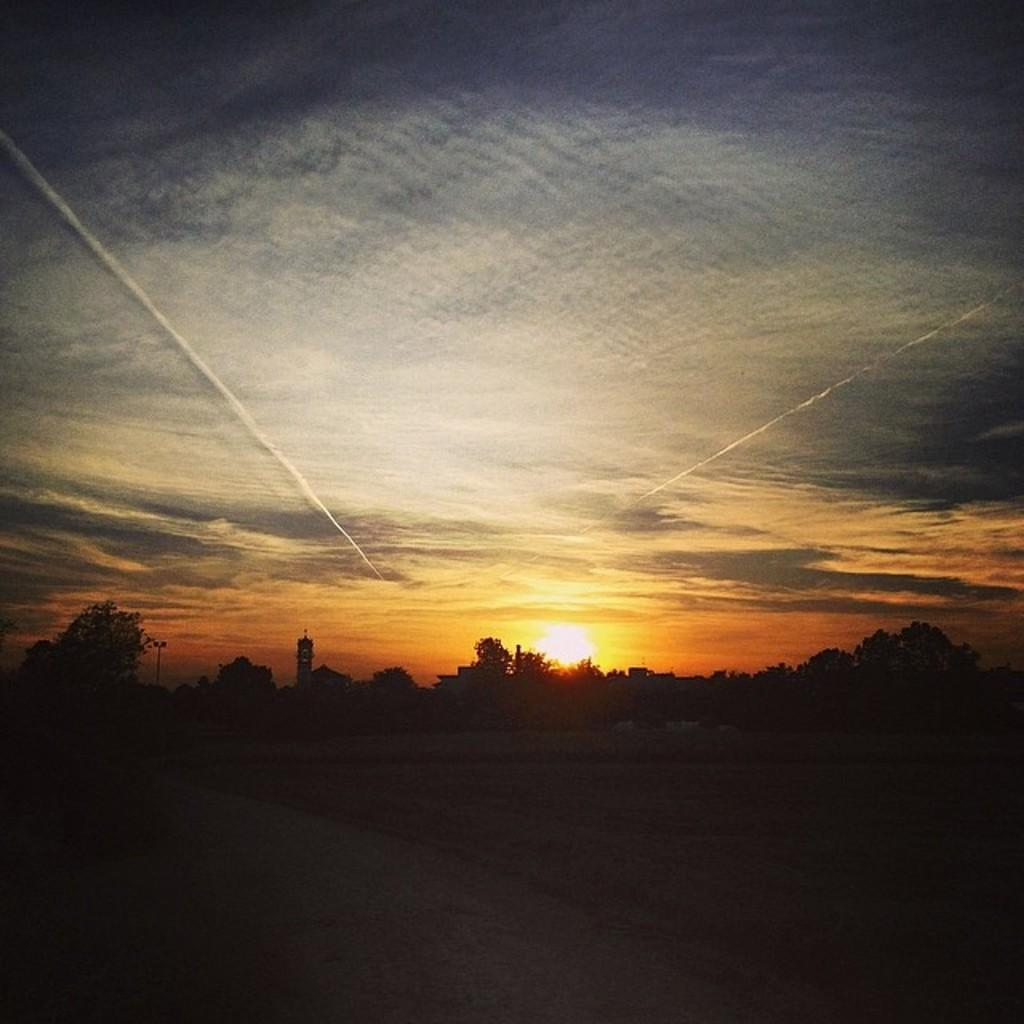What type of vegetation can be seen in the image? There are trees in the image. What is the color of the clouds in the image? There are red color clouds in the image. What celestial body is visible in the image? The sun is visible in the image. What direction are the trees pointing in the image? The trees do not have a specific direction they are pointing in the image; they are stationary and upright. 